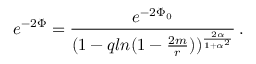Convert formula to latex. <formula><loc_0><loc_0><loc_500><loc_500>e ^ { - 2 \Phi } = { \frac { e ^ { - 2 \Phi _ { 0 } } } { ( 1 - q \ln ( 1 - { \frac { 2 m } { r } } ) ) ^ { \frac { 2 \alpha } { 1 + \alpha ^ { 2 } } } } } \, .</formula> 